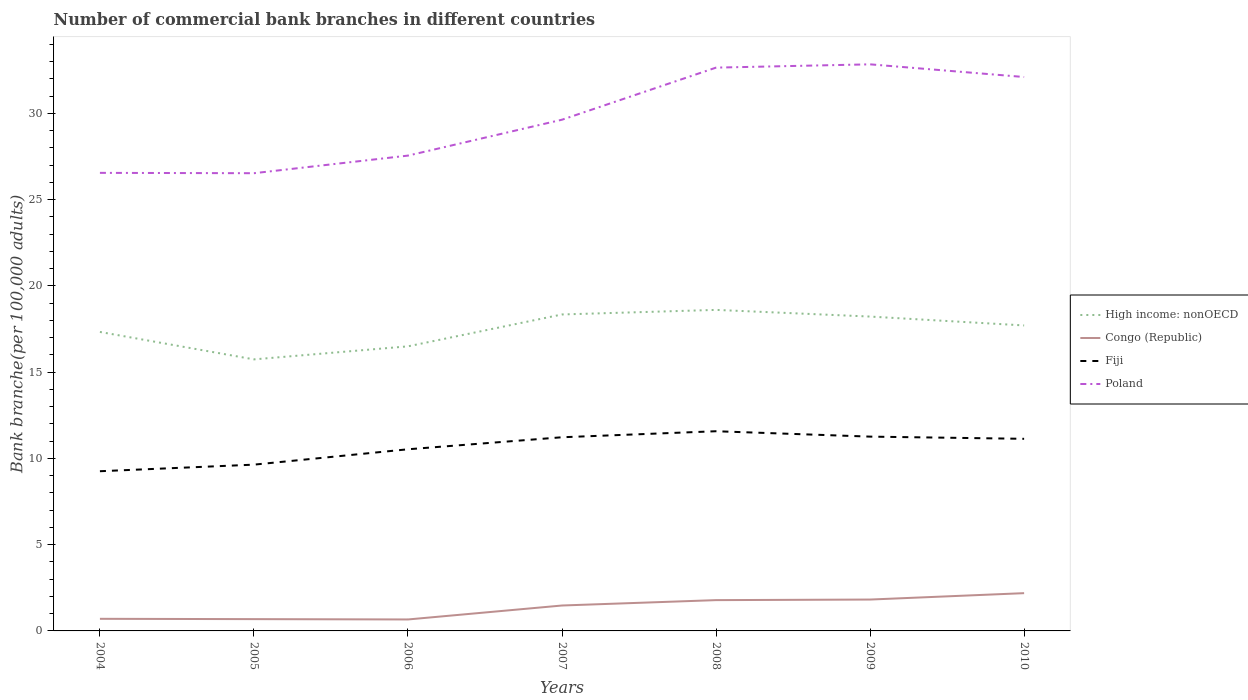Is the number of lines equal to the number of legend labels?
Ensure brevity in your answer.  Yes. Across all years, what is the maximum number of commercial bank branches in Congo (Republic)?
Offer a terse response. 0.66. What is the total number of commercial bank branches in Congo (Republic) in the graph?
Provide a short and direct response. -0.77. What is the difference between the highest and the second highest number of commercial bank branches in Congo (Republic)?
Offer a very short reply. 1.52. What is the difference between the highest and the lowest number of commercial bank branches in Fiji?
Make the answer very short. 4. Is the number of commercial bank branches in Fiji strictly greater than the number of commercial bank branches in High income: nonOECD over the years?
Your response must be concise. Yes. How many lines are there?
Provide a succinct answer. 4. How many years are there in the graph?
Make the answer very short. 7. What is the difference between two consecutive major ticks on the Y-axis?
Your answer should be compact. 5. Are the values on the major ticks of Y-axis written in scientific E-notation?
Provide a succinct answer. No. How many legend labels are there?
Provide a short and direct response. 4. How are the legend labels stacked?
Ensure brevity in your answer.  Vertical. What is the title of the graph?
Ensure brevity in your answer.  Number of commercial bank branches in different countries. Does "Nepal" appear as one of the legend labels in the graph?
Provide a succinct answer. No. What is the label or title of the X-axis?
Your response must be concise. Years. What is the label or title of the Y-axis?
Your response must be concise. Bank branche(per 100,0 adults). What is the Bank branche(per 100,000 adults) in High income: nonOECD in 2004?
Ensure brevity in your answer.  17.33. What is the Bank branche(per 100,000 adults) in Congo (Republic) in 2004?
Provide a succinct answer. 0.7. What is the Bank branche(per 100,000 adults) in Fiji in 2004?
Make the answer very short. 9.26. What is the Bank branche(per 100,000 adults) in Poland in 2004?
Give a very brief answer. 26.55. What is the Bank branche(per 100,000 adults) of High income: nonOECD in 2005?
Make the answer very short. 15.74. What is the Bank branche(per 100,000 adults) of Congo (Republic) in 2005?
Your response must be concise. 0.68. What is the Bank branche(per 100,000 adults) in Fiji in 2005?
Provide a succinct answer. 9.64. What is the Bank branche(per 100,000 adults) of Poland in 2005?
Ensure brevity in your answer.  26.53. What is the Bank branche(per 100,000 adults) of High income: nonOECD in 2006?
Keep it short and to the point. 16.5. What is the Bank branche(per 100,000 adults) in Congo (Republic) in 2006?
Offer a very short reply. 0.66. What is the Bank branche(per 100,000 adults) of Fiji in 2006?
Offer a very short reply. 10.53. What is the Bank branche(per 100,000 adults) in Poland in 2006?
Make the answer very short. 27.55. What is the Bank branche(per 100,000 adults) of High income: nonOECD in 2007?
Offer a very short reply. 18.34. What is the Bank branche(per 100,000 adults) of Congo (Republic) in 2007?
Provide a succinct answer. 1.47. What is the Bank branche(per 100,000 adults) in Fiji in 2007?
Offer a very short reply. 11.23. What is the Bank branche(per 100,000 adults) of Poland in 2007?
Make the answer very short. 29.63. What is the Bank branche(per 100,000 adults) of High income: nonOECD in 2008?
Provide a succinct answer. 18.61. What is the Bank branche(per 100,000 adults) in Congo (Republic) in 2008?
Make the answer very short. 1.79. What is the Bank branche(per 100,000 adults) of Fiji in 2008?
Provide a succinct answer. 11.57. What is the Bank branche(per 100,000 adults) of Poland in 2008?
Provide a succinct answer. 32.65. What is the Bank branche(per 100,000 adults) in High income: nonOECD in 2009?
Your answer should be compact. 18.22. What is the Bank branche(per 100,000 adults) of Congo (Republic) in 2009?
Make the answer very short. 1.82. What is the Bank branche(per 100,000 adults) in Fiji in 2009?
Your answer should be very brief. 11.26. What is the Bank branche(per 100,000 adults) of Poland in 2009?
Make the answer very short. 32.84. What is the Bank branche(per 100,000 adults) in High income: nonOECD in 2010?
Provide a succinct answer. 17.71. What is the Bank branche(per 100,000 adults) in Congo (Republic) in 2010?
Your answer should be compact. 2.19. What is the Bank branche(per 100,000 adults) in Fiji in 2010?
Your answer should be very brief. 11.14. What is the Bank branche(per 100,000 adults) in Poland in 2010?
Offer a very short reply. 32.11. Across all years, what is the maximum Bank branche(per 100,000 adults) in High income: nonOECD?
Ensure brevity in your answer.  18.61. Across all years, what is the maximum Bank branche(per 100,000 adults) in Congo (Republic)?
Offer a very short reply. 2.19. Across all years, what is the maximum Bank branche(per 100,000 adults) in Fiji?
Keep it short and to the point. 11.57. Across all years, what is the maximum Bank branche(per 100,000 adults) of Poland?
Your answer should be compact. 32.84. Across all years, what is the minimum Bank branche(per 100,000 adults) in High income: nonOECD?
Offer a terse response. 15.74. Across all years, what is the minimum Bank branche(per 100,000 adults) of Congo (Republic)?
Your answer should be very brief. 0.66. Across all years, what is the minimum Bank branche(per 100,000 adults) in Fiji?
Make the answer very short. 9.26. Across all years, what is the minimum Bank branche(per 100,000 adults) in Poland?
Give a very brief answer. 26.53. What is the total Bank branche(per 100,000 adults) of High income: nonOECD in the graph?
Provide a short and direct response. 122.44. What is the total Bank branche(per 100,000 adults) in Congo (Republic) in the graph?
Your answer should be compact. 9.32. What is the total Bank branche(per 100,000 adults) in Fiji in the graph?
Offer a very short reply. 74.62. What is the total Bank branche(per 100,000 adults) of Poland in the graph?
Keep it short and to the point. 207.87. What is the difference between the Bank branche(per 100,000 adults) of High income: nonOECD in 2004 and that in 2005?
Ensure brevity in your answer.  1.59. What is the difference between the Bank branche(per 100,000 adults) in Congo (Republic) in 2004 and that in 2005?
Offer a terse response. 0.02. What is the difference between the Bank branche(per 100,000 adults) of Fiji in 2004 and that in 2005?
Keep it short and to the point. -0.38. What is the difference between the Bank branche(per 100,000 adults) of Poland in 2004 and that in 2005?
Provide a short and direct response. 0.02. What is the difference between the Bank branche(per 100,000 adults) of High income: nonOECD in 2004 and that in 2006?
Your answer should be compact. 0.83. What is the difference between the Bank branche(per 100,000 adults) of Congo (Republic) in 2004 and that in 2006?
Your response must be concise. 0.04. What is the difference between the Bank branche(per 100,000 adults) in Fiji in 2004 and that in 2006?
Your answer should be compact. -1.27. What is the difference between the Bank branche(per 100,000 adults) of Poland in 2004 and that in 2006?
Your response must be concise. -1. What is the difference between the Bank branche(per 100,000 adults) in High income: nonOECD in 2004 and that in 2007?
Your answer should be very brief. -1.01. What is the difference between the Bank branche(per 100,000 adults) of Congo (Republic) in 2004 and that in 2007?
Give a very brief answer. -0.77. What is the difference between the Bank branche(per 100,000 adults) in Fiji in 2004 and that in 2007?
Your answer should be very brief. -1.97. What is the difference between the Bank branche(per 100,000 adults) in Poland in 2004 and that in 2007?
Offer a terse response. -3.08. What is the difference between the Bank branche(per 100,000 adults) in High income: nonOECD in 2004 and that in 2008?
Your response must be concise. -1.28. What is the difference between the Bank branche(per 100,000 adults) in Congo (Republic) in 2004 and that in 2008?
Your answer should be very brief. -1.08. What is the difference between the Bank branche(per 100,000 adults) of Fiji in 2004 and that in 2008?
Keep it short and to the point. -2.32. What is the difference between the Bank branche(per 100,000 adults) in Poland in 2004 and that in 2008?
Give a very brief answer. -6.1. What is the difference between the Bank branche(per 100,000 adults) in High income: nonOECD in 2004 and that in 2009?
Offer a very short reply. -0.89. What is the difference between the Bank branche(per 100,000 adults) of Congo (Republic) in 2004 and that in 2009?
Offer a very short reply. -1.12. What is the difference between the Bank branche(per 100,000 adults) of Fiji in 2004 and that in 2009?
Keep it short and to the point. -2.01. What is the difference between the Bank branche(per 100,000 adults) of Poland in 2004 and that in 2009?
Give a very brief answer. -6.29. What is the difference between the Bank branche(per 100,000 adults) of High income: nonOECD in 2004 and that in 2010?
Make the answer very short. -0.38. What is the difference between the Bank branche(per 100,000 adults) of Congo (Republic) in 2004 and that in 2010?
Offer a very short reply. -1.49. What is the difference between the Bank branche(per 100,000 adults) in Fiji in 2004 and that in 2010?
Keep it short and to the point. -1.88. What is the difference between the Bank branche(per 100,000 adults) of Poland in 2004 and that in 2010?
Provide a succinct answer. -5.56. What is the difference between the Bank branche(per 100,000 adults) of High income: nonOECD in 2005 and that in 2006?
Provide a short and direct response. -0.76. What is the difference between the Bank branche(per 100,000 adults) in Congo (Republic) in 2005 and that in 2006?
Your response must be concise. 0.02. What is the difference between the Bank branche(per 100,000 adults) in Fiji in 2005 and that in 2006?
Your answer should be compact. -0.89. What is the difference between the Bank branche(per 100,000 adults) of Poland in 2005 and that in 2006?
Your answer should be very brief. -1.02. What is the difference between the Bank branche(per 100,000 adults) of High income: nonOECD in 2005 and that in 2007?
Your answer should be compact. -2.6. What is the difference between the Bank branche(per 100,000 adults) in Congo (Republic) in 2005 and that in 2007?
Keep it short and to the point. -0.79. What is the difference between the Bank branche(per 100,000 adults) in Fiji in 2005 and that in 2007?
Offer a terse response. -1.59. What is the difference between the Bank branche(per 100,000 adults) in Poland in 2005 and that in 2007?
Give a very brief answer. -3.1. What is the difference between the Bank branche(per 100,000 adults) in High income: nonOECD in 2005 and that in 2008?
Your answer should be compact. -2.87. What is the difference between the Bank branche(per 100,000 adults) of Congo (Republic) in 2005 and that in 2008?
Provide a succinct answer. -1.1. What is the difference between the Bank branche(per 100,000 adults) in Fiji in 2005 and that in 2008?
Provide a succinct answer. -1.94. What is the difference between the Bank branche(per 100,000 adults) in Poland in 2005 and that in 2008?
Give a very brief answer. -6.12. What is the difference between the Bank branche(per 100,000 adults) of High income: nonOECD in 2005 and that in 2009?
Provide a succinct answer. -2.48. What is the difference between the Bank branche(per 100,000 adults) of Congo (Republic) in 2005 and that in 2009?
Keep it short and to the point. -1.13. What is the difference between the Bank branche(per 100,000 adults) in Fiji in 2005 and that in 2009?
Offer a very short reply. -1.62. What is the difference between the Bank branche(per 100,000 adults) of Poland in 2005 and that in 2009?
Ensure brevity in your answer.  -6.31. What is the difference between the Bank branche(per 100,000 adults) in High income: nonOECD in 2005 and that in 2010?
Your response must be concise. -1.97. What is the difference between the Bank branche(per 100,000 adults) in Congo (Republic) in 2005 and that in 2010?
Your answer should be very brief. -1.51. What is the difference between the Bank branche(per 100,000 adults) of Fiji in 2005 and that in 2010?
Provide a succinct answer. -1.5. What is the difference between the Bank branche(per 100,000 adults) in Poland in 2005 and that in 2010?
Ensure brevity in your answer.  -5.58. What is the difference between the Bank branche(per 100,000 adults) of High income: nonOECD in 2006 and that in 2007?
Provide a short and direct response. -1.85. What is the difference between the Bank branche(per 100,000 adults) of Congo (Republic) in 2006 and that in 2007?
Offer a very short reply. -0.81. What is the difference between the Bank branche(per 100,000 adults) of Fiji in 2006 and that in 2007?
Your answer should be very brief. -0.7. What is the difference between the Bank branche(per 100,000 adults) in Poland in 2006 and that in 2007?
Ensure brevity in your answer.  -2.08. What is the difference between the Bank branche(per 100,000 adults) of High income: nonOECD in 2006 and that in 2008?
Offer a terse response. -2.11. What is the difference between the Bank branche(per 100,000 adults) of Congo (Republic) in 2006 and that in 2008?
Offer a very short reply. -1.12. What is the difference between the Bank branche(per 100,000 adults) in Fiji in 2006 and that in 2008?
Give a very brief answer. -1.05. What is the difference between the Bank branche(per 100,000 adults) of Poland in 2006 and that in 2008?
Your response must be concise. -5.1. What is the difference between the Bank branche(per 100,000 adults) of High income: nonOECD in 2006 and that in 2009?
Give a very brief answer. -1.73. What is the difference between the Bank branche(per 100,000 adults) in Congo (Republic) in 2006 and that in 2009?
Make the answer very short. -1.15. What is the difference between the Bank branche(per 100,000 adults) of Fiji in 2006 and that in 2009?
Offer a very short reply. -0.73. What is the difference between the Bank branche(per 100,000 adults) of Poland in 2006 and that in 2009?
Ensure brevity in your answer.  -5.29. What is the difference between the Bank branche(per 100,000 adults) in High income: nonOECD in 2006 and that in 2010?
Give a very brief answer. -1.21. What is the difference between the Bank branche(per 100,000 adults) of Congo (Republic) in 2006 and that in 2010?
Your answer should be compact. -1.52. What is the difference between the Bank branche(per 100,000 adults) of Fiji in 2006 and that in 2010?
Your answer should be compact. -0.61. What is the difference between the Bank branche(per 100,000 adults) in Poland in 2006 and that in 2010?
Your answer should be compact. -4.56. What is the difference between the Bank branche(per 100,000 adults) of High income: nonOECD in 2007 and that in 2008?
Your answer should be very brief. -0.26. What is the difference between the Bank branche(per 100,000 adults) of Congo (Republic) in 2007 and that in 2008?
Keep it short and to the point. -0.31. What is the difference between the Bank branche(per 100,000 adults) in Fiji in 2007 and that in 2008?
Ensure brevity in your answer.  -0.35. What is the difference between the Bank branche(per 100,000 adults) of Poland in 2007 and that in 2008?
Your answer should be very brief. -3.02. What is the difference between the Bank branche(per 100,000 adults) of High income: nonOECD in 2007 and that in 2009?
Keep it short and to the point. 0.12. What is the difference between the Bank branche(per 100,000 adults) of Congo (Republic) in 2007 and that in 2009?
Keep it short and to the point. -0.35. What is the difference between the Bank branche(per 100,000 adults) of Fiji in 2007 and that in 2009?
Give a very brief answer. -0.04. What is the difference between the Bank branche(per 100,000 adults) in Poland in 2007 and that in 2009?
Provide a short and direct response. -3.21. What is the difference between the Bank branche(per 100,000 adults) of High income: nonOECD in 2007 and that in 2010?
Provide a short and direct response. 0.64. What is the difference between the Bank branche(per 100,000 adults) of Congo (Republic) in 2007 and that in 2010?
Offer a terse response. -0.72. What is the difference between the Bank branche(per 100,000 adults) of Fiji in 2007 and that in 2010?
Ensure brevity in your answer.  0.09. What is the difference between the Bank branche(per 100,000 adults) of Poland in 2007 and that in 2010?
Give a very brief answer. -2.47. What is the difference between the Bank branche(per 100,000 adults) in High income: nonOECD in 2008 and that in 2009?
Offer a terse response. 0.39. What is the difference between the Bank branche(per 100,000 adults) of Congo (Republic) in 2008 and that in 2009?
Keep it short and to the point. -0.03. What is the difference between the Bank branche(per 100,000 adults) in Fiji in 2008 and that in 2009?
Your response must be concise. 0.31. What is the difference between the Bank branche(per 100,000 adults) of Poland in 2008 and that in 2009?
Your response must be concise. -0.19. What is the difference between the Bank branche(per 100,000 adults) in High income: nonOECD in 2008 and that in 2010?
Provide a short and direct response. 0.9. What is the difference between the Bank branche(per 100,000 adults) of Congo (Republic) in 2008 and that in 2010?
Keep it short and to the point. -0.4. What is the difference between the Bank branche(per 100,000 adults) of Fiji in 2008 and that in 2010?
Make the answer very short. 0.44. What is the difference between the Bank branche(per 100,000 adults) in Poland in 2008 and that in 2010?
Provide a succinct answer. 0.54. What is the difference between the Bank branche(per 100,000 adults) of High income: nonOECD in 2009 and that in 2010?
Provide a short and direct response. 0.51. What is the difference between the Bank branche(per 100,000 adults) of Congo (Republic) in 2009 and that in 2010?
Give a very brief answer. -0.37. What is the difference between the Bank branche(per 100,000 adults) of Fiji in 2009 and that in 2010?
Make the answer very short. 0.13. What is the difference between the Bank branche(per 100,000 adults) of Poland in 2009 and that in 2010?
Offer a very short reply. 0.74. What is the difference between the Bank branche(per 100,000 adults) in High income: nonOECD in 2004 and the Bank branche(per 100,000 adults) in Congo (Republic) in 2005?
Offer a very short reply. 16.65. What is the difference between the Bank branche(per 100,000 adults) in High income: nonOECD in 2004 and the Bank branche(per 100,000 adults) in Fiji in 2005?
Keep it short and to the point. 7.69. What is the difference between the Bank branche(per 100,000 adults) of High income: nonOECD in 2004 and the Bank branche(per 100,000 adults) of Poland in 2005?
Offer a terse response. -9.2. What is the difference between the Bank branche(per 100,000 adults) of Congo (Republic) in 2004 and the Bank branche(per 100,000 adults) of Fiji in 2005?
Make the answer very short. -8.94. What is the difference between the Bank branche(per 100,000 adults) of Congo (Republic) in 2004 and the Bank branche(per 100,000 adults) of Poland in 2005?
Your answer should be very brief. -25.83. What is the difference between the Bank branche(per 100,000 adults) in Fiji in 2004 and the Bank branche(per 100,000 adults) in Poland in 2005?
Offer a terse response. -17.27. What is the difference between the Bank branche(per 100,000 adults) in High income: nonOECD in 2004 and the Bank branche(per 100,000 adults) in Congo (Republic) in 2006?
Provide a short and direct response. 16.67. What is the difference between the Bank branche(per 100,000 adults) of High income: nonOECD in 2004 and the Bank branche(per 100,000 adults) of Fiji in 2006?
Provide a short and direct response. 6.8. What is the difference between the Bank branche(per 100,000 adults) in High income: nonOECD in 2004 and the Bank branche(per 100,000 adults) in Poland in 2006?
Offer a very short reply. -10.22. What is the difference between the Bank branche(per 100,000 adults) of Congo (Republic) in 2004 and the Bank branche(per 100,000 adults) of Fiji in 2006?
Ensure brevity in your answer.  -9.83. What is the difference between the Bank branche(per 100,000 adults) of Congo (Republic) in 2004 and the Bank branche(per 100,000 adults) of Poland in 2006?
Ensure brevity in your answer.  -26.85. What is the difference between the Bank branche(per 100,000 adults) of Fiji in 2004 and the Bank branche(per 100,000 adults) of Poland in 2006?
Keep it short and to the point. -18.3. What is the difference between the Bank branche(per 100,000 adults) of High income: nonOECD in 2004 and the Bank branche(per 100,000 adults) of Congo (Republic) in 2007?
Your answer should be compact. 15.86. What is the difference between the Bank branche(per 100,000 adults) in High income: nonOECD in 2004 and the Bank branche(per 100,000 adults) in Fiji in 2007?
Your answer should be very brief. 6.1. What is the difference between the Bank branche(per 100,000 adults) of High income: nonOECD in 2004 and the Bank branche(per 100,000 adults) of Poland in 2007?
Give a very brief answer. -12.3. What is the difference between the Bank branche(per 100,000 adults) in Congo (Republic) in 2004 and the Bank branche(per 100,000 adults) in Fiji in 2007?
Keep it short and to the point. -10.52. What is the difference between the Bank branche(per 100,000 adults) of Congo (Republic) in 2004 and the Bank branche(per 100,000 adults) of Poland in 2007?
Your answer should be very brief. -28.93. What is the difference between the Bank branche(per 100,000 adults) of Fiji in 2004 and the Bank branche(per 100,000 adults) of Poland in 2007?
Your response must be concise. -20.38. What is the difference between the Bank branche(per 100,000 adults) of High income: nonOECD in 2004 and the Bank branche(per 100,000 adults) of Congo (Republic) in 2008?
Keep it short and to the point. 15.54. What is the difference between the Bank branche(per 100,000 adults) in High income: nonOECD in 2004 and the Bank branche(per 100,000 adults) in Fiji in 2008?
Keep it short and to the point. 5.76. What is the difference between the Bank branche(per 100,000 adults) in High income: nonOECD in 2004 and the Bank branche(per 100,000 adults) in Poland in 2008?
Your answer should be compact. -15.32. What is the difference between the Bank branche(per 100,000 adults) of Congo (Republic) in 2004 and the Bank branche(per 100,000 adults) of Fiji in 2008?
Keep it short and to the point. -10.87. What is the difference between the Bank branche(per 100,000 adults) in Congo (Republic) in 2004 and the Bank branche(per 100,000 adults) in Poland in 2008?
Make the answer very short. -31.95. What is the difference between the Bank branche(per 100,000 adults) in Fiji in 2004 and the Bank branche(per 100,000 adults) in Poland in 2008?
Offer a very short reply. -23.39. What is the difference between the Bank branche(per 100,000 adults) of High income: nonOECD in 2004 and the Bank branche(per 100,000 adults) of Congo (Republic) in 2009?
Your response must be concise. 15.51. What is the difference between the Bank branche(per 100,000 adults) of High income: nonOECD in 2004 and the Bank branche(per 100,000 adults) of Fiji in 2009?
Provide a short and direct response. 6.07. What is the difference between the Bank branche(per 100,000 adults) in High income: nonOECD in 2004 and the Bank branche(per 100,000 adults) in Poland in 2009?
Make the answer very short. -15.51. What is the difference between the Bank branche(per 100,000 adults) in Congo (Republic) in 2004 and the Bank branche(per 100,000 adults) in Fiji in 2009?
Give a very brief answer. -10.56. What is the difference between the Bank branche(per 100,000 adults) in Congo (Republic) in 2004 and the Bank branche(per 100,000 adults) in Poland in 2009?
Keep it short and to the point. -32.14. What is the difference between the Bank branche(per 100,000 adults) of Fiji in 2004 and the Bank branche(per 100,000 adults) of Poland in 2009?
Offer a terse response. -23.59. What is the difference between the Bank branche(per 100,000 adults) in High income: nonOECD in 2004 and the Bank branche(per 100,000 adults) in Congo (Republic) in 2010?
Keep it short and to the point. 15.14. What is the difference between the Bank branche(per 100,000 adults) in High income: nonOECD in 2004 and the Bank branche(per 100,000 adults) in Fiji in 2010?
Provide a succinct answer. 6.19. What is the difference between the Bank branche(per 100,000 adults) of High income: nonOECD in 2004 and the Bank branche(per 100,000 adults) of Poland in 2010?
Provide a short and direct response. -14.78. What is the difference between the Bank branche(per 100,000 adults) in Congo (Republic) in 2004 and the Bank branche(per 100,000 adults) in Fiji in 2010?
Provide a short and direct response. -10.43. What is the difference between the Bank branche(per 100,000 adults) in Congo (Republic) in 2004 and the Bank branche(per 100,000 adults) in Poland in 2010?
Make the answer very short. -31.4. What is the difference between the Bank branche(per 100,000 adults) in Fiji in 2004 and the Bank branche(per 100,000 adults) in Poland in 2010?
Provide a short and direct response. -22.85. What is the difference between the Bank branche(per 100,000 adults) in High income: nonOECD in 2005 and the Bank branche(per 100,000 adults) in Congo (Republic) in 2006?
Ensure brevity in your answer.  15.08. What is the difference between the Bank branche(per 100,000 adults) in High income: nonOECD in 2005 and the Bank branche(per 100,000 adults) in Fiji in 2006?
Ensure brevity in your answer.  5.21. What is the difference between the Bank branche(per 100,000 adults) of High income: nonOECD in 2005 and the Bank branche(per 100,000 adults) of Poland in 2006?
Ensure brevity in your answer.  -11.81. What is the difference between the Bank branche(per 100,000 adults) in Congo (Republic) in 2005 and the Bank branche(per 100,000 adults) in Fiji in 2006?
Provide a short and direct response. -9.85. What is the difference between the Bank branche(per 100,000 adults) of Congo (Republic) in 2005 and the Bank branche(per 100,000 adults) of Poland in 2006?
Ensure brevity in your answer.  -26.87. What is the difference between the Bank branche(per 100,000 adults) of Fiji in 2005 and the Bank branche(per 100,000 adults) of Poland in 2006?
Your answer should be very brief. -17.91. What is the difference between the Bank branche(per 100,000 adults) of High income: nonOECD in 2005 and the Bank branche(per 100,000 adults) of Congo (Republic) in 2007?
Offer a very short reply. 14.27. What is the difference between the Bank branche(per 100,000 adults) in High income: nonOECD in 2005 and the Bank branche(per 100,000 adults) in Fiji in 2007?
Ensure brevity in your answer.  4.51. What is the difference between the Bank branche(per 100,000 adults) of High income: nonOECD in 2005 and the Bank branche(per 100,000 adults) of Poland in 2007?
Provide a succinct answer. -13.89. What is the difference between the Bank branche(per 100,000 adults) in Congo (Republic) in 2005 and the Bank branche(per 100,000 adults) in Fiji in 2007?
Give a very brief answer. -10.54. What is the difference between the Bank branche(per 100,000 adults) in Congo (Republic) in 2005 and the Bank branche(per 100,000 adults) in Poland in 2007?
Offer a terse response. -28.95. What is the difference between the Bank branche(per 100,000 adults) in Fiji in 2005 and the Bank branche(per 100,000 adults) in Poland in 2007?
Your response must be concise. -19.99. What is the difference between the Bank branche(per 100,000 adults) in High income: nonOECD in 2005 and the Bank branche(per 100,000 adults) in Congo (Republic) in 2008?
Offer a terse response. 13.95. What is the difference between the Bank branche(per 100,000 adults) of High income: nonOECD in 2005 and the Bank branche(per 100,000 adults) of Fiji in 2008?
Give a very brief answer. 4.17. What is the difference between the Bank branche(per 100,000 adults) of High income: nonOECD in 2005 and the Bank branche(per 100,000 adults) of Poland in 2008?
Offer a terse response. -16.91. What is the difference between the Bank branche(per 100,000 adults) in Congo (Republic) in 2005 and the Bank branche(per 100,000 adults) in Fiji in 2008?
Make the answer very short. -10.89. What is the difference between the Bank branche(per 100,000 adults) in Congo (Republic) in 2005 and the Bank branche(per 100,000 adults) in Poland in 2008?
Make the answer very short. -31.97. What is the difference between the Bank branche(per 100,000 adults) in Fiji in 2005 and the Bank branche(per 100,000 adults) in Poland in 2008?
Provide a short and direct response. -23.01. What is the difference between the Bank branche(per 100,000 adults) in High income: nonOECD in 2005 and the Bank branche(per 100,000 adults) in Congo (Republic) in 2009?
Make the answer very short. 13.92. What is the difference between the Bank branche(per 100,000 adults) of High income: nonOECD in 2005 and the Bank branche(per 100,000 adults) of Fiji in 2009?
Provide a short and direct response. 4.48. What is the difference between the Bank branche(per 100,000 adults) of High income: nonOECD in 2005 and the Bank branche(per 100,000 adults) of Poland in 2009?
Offer a terse response. -17.1. What is the difference between the Bank branche(per 100,000 adults) of Congo (Republic) in 2005 and the Bank branche(per 100,000 adults) of Fiji in 2009?
Provide a short and direct response. -10.58. What is the difference between the Bank branche(per 100,000 adults) of Congo (Republic) in 2005 and the Bank branche(per 100,000 adults) of Poland in 2009?
Your answer should be compact. -32.16. What is the difference between the Bank branche(per 100,000 adults) of Fiji in 2005 and the Bank branche(per 100,000 adults) of Poland in 2009?
Give a very brief answer. -23.2. What is the difference between the Bank branche(per 100,000 adults) in High income: nonOECD in 2005 and the Bank branche(per 100,000 adults) in Congo (Republic) in 2010?
Your answer should be very brief. 13.55. What is the difference between the Bank branche(per 100,000 adults) of High income: nonOECD in 2005 and the Bank branche(per 100,000 adults) of Fiji in 2010?
Your response must be concise. 4.6. What is the difference between the Bank branche(per 100,000 adults) of High income: nonOECD in 2005 and the Bank branche(per 100,000 adults) of Poland in 2010?
Offer a terse response. -16.37. What is the difference between the Bank branche(per 100,000 adults) in Congo (Republic) in 2005 and the Bank branche(per 100,000 adults) in Fiji in 2010?
Your answer should be compact. -10.45. What is the difference between the Bank branche(per 100,000 adults) in Congo (Republic) in 2005 and the Bank branche(per 100,000 adults) in Poland in 2010?
Keep it short and to the point. -31.42. What is the difference between the Bank branche(per 100,000 adults) in Fiji in 2005 and the Bank branche(per 100,000 adults) in Poland in 2010?
Your answer should be compact. -22.47. What is the difference between the Bank branche(per 100,000 adults) in High income: nonOECD in 2006 and the Bank branche(per 100,000 adults) in Congo (Republic) in 2007?
Your answer should be very brief. 15.02. What is the difference between the Bank branche(per 100,000 adults) in High income: nonOECD in 2006 and the Bank branche(per 100,000 adults) in Fiji in 2007?
Make the answer very short. 5.27. What is the difference between the Bank branche(per 100,000 adults) of High income: nonOECD in 2006 and the Bank branche(per 100,000 adults) of Poland in 2007?
Offer a terse response. -13.14. What is the difference between the Bank branche(per 100,000 adults) in Congo (Republic) in 2006 and the Bank branche(per 100,000 adults) in Fiji in 2007?
Ensure brevity in your answer.  -10.56. What is the difference between the Bank branche(per 100,000 adults) in Congo (Republic) in 2006 and the Bank branche(per 100,000 adults) in Poland in 2007?
Your response must be concise. -28.97. What is the difference between the Bank branche(per 100,000 adults) in Fiji in 2006 and the Bank branche(per 100,000 adults) in Poland in 2007?
Make the answer very short. -19.1. What is the difference between the Bank branche(per 100,000 adults) in High income: nonOECD in 2006 and the Bank branche(per 100,000 adults) in Congo (Republic) in 2008?
Make the answer very short. 14.71. What is the difference between the Bank branche(per 100,000 adults) of High income: nonOECD in 2006 and the Bank branche(per 100,000 adults) of Fiji in 2008?
Offer a terse response. 4.92. What is the difference between the Bank branche(per 100,000 adults) of High income: nonOECD in 2006 and the Bank branche(per 100,000 adults) of Poland in 2008?
Make the answer very short. -16.16. What is the difference between the Bank branche(per 100,000 adults) in Congo (Republic) in 2006 and the Bank branche(per 100,000 adults) in Fiji in 2008?
Your answer should be compact. -10.91. What is the difference between the Bank branche(per 100,000 adults) of Congo (Republic) in 2006 and the Bank branche(per 100,000 adults) of Poland in 2008?
Your answer should be very brief. -31.99. What is the difference between the Bank branche(per 100,000 adults) of Fiji in 2006 and the Bank branche(per 100,000 adults) of Poland in 2008?
Your answer should be very brief. -22.12. What is the difference between the Bank branche(per 100,000 adults) in High income: nonOECD in 2006 and the Bank branche(per 100,000 adults) in Congo (Republic) in 2009?
Your answer should be very brief. 14.68. What is the difference between the Bank branche(per 100,000 adults) in High income: nonOECD in 2006 and the Bank branche(per 100,000 adults) in Fiji in 2009?
Your answer should be very brief. 5.23. What is the difference between the Bank branche(per 100,000 adults) of High income: nonOECD in 2006 and the Bank branche(per 100,000 adults) of Poland in 2009?
Make the answer very short. -16.35. What is the difference between the Bank branche(per 100,000 adults) in Congo (Republic) in 2006 and the Bank branche(per 100,000 adults) in Fiji in 2009?
Ensure brevity in your answer.  -10.6. What is the difference between the Bank branche(per 100,000 adults) in Congo (Republic) in 2006 and the Bank branche(per 100,000 adults) in Poland in 2009?
Make the answer very short. -32.18. What is the difference between the Bank branche(per 100,000 adults) of Fiji in 2006 and the Bank branche(per 100,000 adults) of Poland in 2009?
Provide a short and direct response. -22.31. What is the difference between the Bank branche(per 100,000 adults) in High income: nonOECD in 2006 and the Bank branche(per 100,000 adults) in Congo (Republic) in 2010?
Your response must be concise. 14.31. What is the difference between the Bank branche(per 100,000 adults) of High income: nonOECD in 2006 and the Bank branche(per 100,000 adults) of Fiji in 2010?
Provide a short and direct response. 5.36. What is the difference between the Bank branche(per 100,000 adults) of High income: nonOECD in 2006 and the Bank branche(per 100,000 adults) of Poland in 2010?
Offer a very short reply. -15.61. What is the difference between the Bank branche(per 100,000 adults) in Congo (Republic) in 2006 and the Bank branche(per 100,000 adults) in Fiji in 2010?
Make the answer very short. -10.47. What is the difference between the Bank branche(per 100,000 adults) in Congo (Republic) in 2006 and the Bank branche(per 100,000 adults) in Poland in 2010?
Make the answer very short. -31.44. What is the difference between the Bank branche(per 100,000 adults) of Fiji in 2006 and the Bank branche(per 100,000 adults) of Poland in 2010?
Make the answer very short. -21.58. What is the difference between the Bank branche(per 100,000 adults) in High income: nonOECD in 2007 and the Bank branche(per 100,000 adults) in Congo (Republic) in 2008?
Your answer should be very brief. 16.56. What is the difference between the Bank branche(per 100,000 adults) in High income: nonOECD in 2007 and the Bank branche(per 100,000 adults) in Fiji in 2008?
Your answer should be compact. 6.77. What is the difference between the Bank branche(per 100,000 adults) of High income: nonOECD in 2007 and the Bank branche(per 100,000 adults) of Poland in 2008?
Your answer should be compact. -14.31. What is the difference between the Bank branche(per 100,000 adults) in Congo (Republic) in 2007 and the Bank branche(per 100,000 adults) in Fiji in 2008?
Offer a terse response. -10.1. What is the difference between the Bank branche(per 100,000 adults) of Congo (Republic) in 2007 and the Bank branche(per 100,000 adults) of Poland in 2008?
Make the answer very short. -31.18. What is the difference between the Bank branche(per 100,000 adults) in Fiji in 2007 and the Bank branche(per 100,000 adults) in Poland in 2008?
Your response must be concise. -21.43. What is the difference between the Bank branche(per 100,000 adults) in High income: nonOECD in 2007 and the Bank branche(per 100,000 adults) in Congo (Republic) in 2009?
Offer a very short reply. 16.52. What is the difference between the Bank branche(per 100,000 adults) in High income: nonOECD in 2007 and the Bank branche(per 100,000 adults) in Fiji in 2009?
Your response must be concise. 7.08. What is the difference between the Bank branche(per 100,000 adults) of High income: nonOECD in 2007 and the Bank branche(per 100,000 adults) of Poland in 2009?
Offer a terse response. -14.5. What is the difference between the Bank branche(per 100,000 adults) in Congo (Republic) in 2007 and the Bank branche(per 100,000 adults) in Fiji in 2009?
Provide a succinct answer. -9.79. What is the difference between the Bank branche(per 100,000 adults) in Congo (Republic) in 2007 and the Bank branche(per 100,000 adults) in Poland in 2009?
Your response must be concise. -31.37. What is the difference between the Bank branche(per 100,000 adults) in Fiji in 2007 and the Bank branche(per 100,000 adults) in Poland in 2009?
Provide a succinct answer. -21.62. What is the difference between the Bank branche(per 100,000 adults) of High income: nonOECD in 2007 and the Bank branche(per 100,000 adults) of Congo (Republic) in 2010?
Your answer should be compact. 16.15. What is the difference between the Bank branche(per 100,000 adults) of High income: nonOECD in 2007 and the Bank branche(per 100,000 adults) of Fiji in 2010?
Offer a very short reply. 7.21. What is the difference between the Bank branche(per 100,000 adults) of High income: nonOECD in 2007 and the Bank branche(per 100,000 adults) of Poland in 2010?
Offer a terse response. -13.76. What is the difference between the Bank branche(per 100,000 adults) of Congo (Republic) in 2007 and the Bank branche(per 100,000 adults) of Fiji in 2010?
Your response must be concise. -9.66. What is the difference between the Bank branche(per 100,000 adults) of Congo (Republic) in 2007 and the Bank branche(per 100,000 adults) of Poland in 2010?
Make the answer very short. -30.63. What is the difference between the Bank branche(per 100,000 adults) of Fiji in 2007 and the Bank branche(per 100,000 adults) of Poland in 2010?
Ensure brevity in your answer.  -20.88. What is the difference between the Bank branche(per 100,000 adults) in High income: nonOECD in 2008 and the Bank branche(per 100,000 adults) in Congo (Republic) in 2009?
Give a very brief answer. 16.79. What is the difference between the Bank branche(per 100,000 adults) in High income: nonOECD in 2008 and the Bank branche(per 100,000 adults) in Fiji in 2009?
Offer a terse response. 7.35. What is the difference between the Bank branche(per 100,000 adults) of High income: nonOECD in 2008 and the Bank branche(per 100,000 adults) of Poland in 2009?
Your answer should be very brief. -14.23. What is the difference between the Bank branche(per 100,000 adults) of Congo (Republic) in 2008 and the Bank branche(per 100,000 adults) of Fiji in 2009?
Provide a succinct answer. -9.48. What is the difference between the Bank branche(per 100,000 adults) of Congo (Republic) in 2008 and the Bank branche(per 100,000 adults) of Poland in 2009?
Your answer should be very brief. -31.06. What is the difference between the Bank branche(per 100,000 adults) in Fiji in 2008 and the Bank branche(per 100,000 adults) in Poland in 2009?
Provide a succinct answer. -21.27. What is the difference between the Bank branche(per 100,000 adults) in High income: nonOECD in 2008 and the Bank branche(per 100,000 adults) in Congo (Republic) in 2010?
Make the answer very short. 16.42. What is the difference between the Bank branche(per 100,000 adults) in High income: nonOECD in 2008 and the Bank branche(per 100,000 adults) in Fiji in 2010?
Offer a very short reply. 7.47. What is the difference between the Bank branche(per 100,000 adults) of High income: nonOECD in 2008 and the Bank branche(per 100,000 adults) of Poland in 2010?
Your answer should be compact. -13.5. What is the difference between the Bank branche(per 100,000 adults) of Congo (Republic) in 2008 and the Bank branche(per 100,000 adults) of Fiji in 2010?
Offer a very short reply. -9.35. What is the difference between the Bank branche(per 100,000 adults) in Congo (Republic) in 2008 and the Bank branche(per 100,000 adults) in Poland in 2010?
Your answer should be compact. -30.32. What is the difference between the Bank branche(per 100,000 adults) of Fiji in 2008 and the Bank branche(per 100,000 adults) of Poland in 2010?
Your response must be concise. -20.53. What is the difference between the Bank branche(per 100,000 adults) of High income: nonOECD in 2009 and the Bank branche(per 100,000 adults) of Congo (Republic) in 2010?
Give a very brief answer. 16.03. What is the difference between the Bank branche(per 100,000 adults) in High income: nonOECD in 2009 and the Bank branche(per 100,000 adults) in Fiji in 2010?
Make the answer very short. 7.09. What is the difference between the Bank branche(per 100,000 adults) of High income: nonOECD in 2009 and the Bank branche(per 100,000 adults) of Poland in 2010?
Offer a very short reply. -13.89. What is the difference between the Bank branche(per 100,000 adults) of Congo (Republic) in 2009 and the Bank branche(per 100,000 adults) of Fiji in 2010?
Give a very brief answer. -9.32. What is the difference between the Bank branche(per 100,000 adults) in Congo (Republic) in 2009 and the Bank branche(per 100,000 adults) in Poland in 2010?
Provide a succinct answer. -30.29. What is the difference between the Bank branche(per 100,000 adults) of Fiji in 2009 and the Bank branche(per 100,000 adults) of Poland in 2010?
Provide a succinct answer. -20.84. What is the average Bank branche(per 100,000 adults) in High income: nonOECD per year?
Your response must be concise. 17.49. What is the average Bank branche(per 100,000 adults) of Congo (Republic) per year?
Your answer should be very brief. 1.33. What is the average Bank branche(per 100,000 adults) of Fiji per year?
Provide a succinct answer. 10.66. What is the average Bank branche(per 100,000 adults) of Poland per year?
Provide a short and direct response. 29.7. In the year 2004, what is the difference between the Bank branche(per 100,000 adults) of High income: nonOECD and Bank branche(per 100,000 adults) of Congo (Republic)?
Offer a very short reply. 16.63. In the year 2004, what is the difference between the Bank branche(per 100,000 adults) of High income: nonOECD and Bank branche(per 100,000 adults) of Fiji?
Your answer should be very brief. 8.07. In the year 2004, what is the difference between the Bank branche(per 100,000 adults) of High income: nonOECD and Bank branche(per 100,000 adults) of Poland?
Give a very brief answer. -9.22. In the year 2004, what is the difference between the Bank branche(per 100,000 adults) in Congo (Republic) and Bank branche(per 100,000 adults) in Fiji?
Your answer should be compact. -8.55. In the year 2004, what is the difference between the Bank branche(per 100,000 adults) in Congo (Republic) and Bank branche(per 100,000 adults) in Poland?
Ensure brevity in your answer.  -25.85. In the year 2004, what is the difference between the Bank branche(per 100,000 adults) in Fiji and Bank branche(per 100,000 adults) in Poland?
Keep it short and to the point. -17.29. In the year 2005, what is the difference between the Bank branche(per 100,000 adults) in High income: nonOECD and Bank branche(per 100,000 adults) in Congo (Republic)?
Offer a terse response. 15.06. In the year 2005, what is the difference between the Bank branche(per 100,000 adults) of High income: nonOECD and Bank branche(per 100,000 adults) of Fiji?
Give a very brief answer. 6.1. In the year 2005, what is the difference between the Bank branche(per 100,000 adults) of High income: nonOECD and Bank branche(per 100,000 adults) of Poland?
Provide a succinct answer. -10.79. In the year 2005, what is the difference between the Bank branche(per 100,000 adults) of Congo (Republic) and Bank branche(per 100,000 adults) of Fiji?
Keep it short and to the point. -8.95. In the year 2005, what is the difference between the Bank branche(per 100,000 adults) in Congo (Republic) and Bank branche(per 100,000 adults) in Poland?
Provide a succinct answer. -25.85. In the year 2005, what is the difference between the Bank branche(per 100,000 adults) of Fiji and Bank branche(per 100,000 adults) of Poland?
Ensure brevity in your answer.  -16.89. In the year 2006, what is the difference between the Bank branche(per 100,000 adults) of High income: nonOECD and Bank branche(per 100,000 adults) of Congo (Republic)?
Give a very brief answer. 15.83. In the year 2006, what is the difference between the Bank branche(per 100,000 adults) of High income: nonOECD and Bank branche(per 100,000 adults) of Fiji?
Your answer should be very brief. 5.97. In the year 2006, what is the difference between the Bank branche(per 100,000 adults) in High income: nonOECD and Bank branche(per 100,000 adults) in Poland?
Your answer should be compact. -11.06. In the year 2006, what is the difference between the Bank branche(per 100,000 adults) in Congo (Republic) and Bank branche(per 100,000 adults) in Fiji?
Provide a short and direct response. -9.86. In the year 2006, what is the difference between the Bank branche(per 100,000 adults) in Congo (Republic) and Bank branche(per 100,000 adults) in Poland?
Provide a succinct answer. -26.89. In the year 2006, what is the difference between the Bank branche(per 100,000 adults) in Fiji and Bank branche(per 100,000 adults) in Poland?
Offer a terse response. -17.02. In the year 2007, what is the difference between the Bank branche(per 100,000 adults) in High income: nonOECD and Bank branche(per 100,000 adults) in Congo (Republic)?
Offer a terse response. 16.87. In the year 2007, what is the difference between the Bank branche(per 100,000 adults) of High income: nonOECD and Bank branche(per 100,000 adults) of Fiji?
Make the answer very short. 7.12. In the year 2007, what is the difference between the Bank branche(per 100,000 adults) in High income: nonOECD and Bank branche(per 100,000 adults) in Poland?
Provide a short and direct response. -11.29. In the year 2007, what is the difference between the Bank branche(per 100,000 adults) of Congo (Republic) and Bank branche(per 100,000 adults) of Fiji?
Your response must be concise. -9.75. In the year 2007, what is the difference between the Bank branche(per 100,000 adults) in Congo (Republic) and Bank branche(per 100,000 adults) in Poland?
Give a very brief answer. -28.16. In the year 2007, what is the difference between the Bank branche(per 100,000 adults) of Fiji and Bank branche(per 100,000 adults) of Poland?
Your response must be concise. -18.41. In the year 2008, what is the difference between the Bank branche(per 100,000 adults) in High income: nonOECD and Bank branche(per 100,000 adults) in Congo (Republic)?
Provide a succinct answer. 16.82. In the year 2008, what is the difference between the Bank branche(per 100,000 adults) of High income: nonOECD and Bank branche(per 100,000 adults) of Fiji?
Your response must be concise. 7.03. In the year 2008, what is the difference between the Bank branche(per 100,000 adults) in High income: nonOECD and Bank branche(per 100,000 adults) in Poland?
Keep it short and to the point. -14.04. In the year 2008, what is the difference between the Bank branche(per 100,000 adults) of Congo (Republic) and Bank branche(per 100,000 adults) of Fiji?
Ensure brevity in your answer.  -9.79. In the year 2008, what is the difference between the Bank branche(per 100,000 adults) in Congo (Republic) and Bank branche(per 100,000 adults) in Poland?
Your answer should be very brief. -30.87. In the year 2008, what is the difference between the Bank branche(per 100,000 adults) of Fiji and Bank branche(per 100,000 adults) of Poland?
Make the answer very short. -21.08. In the year 2009, what is the difference between the Bank branche(per 100,000 adults) in High income: nonOECD and Bank branche(per 100,000 adults) in Congo (Republic)?
Give a very brief answer. 16.4. In the year 2009, what is the difference between the Bank branche(per 100,000 adults) in High income: nonOECD and Bank branche(per 100,000 adults) in Fiji?
Give a very brief answer. 6.96. In the year 2009, what is the difference between the Bank branche(per 100,000 adults) in High income: nonOECD and Bank branche(per 100,000 adults) in Poland?
Your answer should be very brief. -14.62. In the year 2009, what is the difference between the Bank branche(per 100,000 adults) of Congo (Republic) and Bank branche(per 100,000 adults) of Fiji?
Provide a succinct answer. -9.44. In the year 2009, what is the difference between the Bank branche(per 100,000 adults) of Congo (Republic) and Bank branche(per 100,000 adults) of Poland?
Provide a succinct answer. -31.02. In the year 2009, what is the difference between the Bank branche(per 100,000 adults) of Fiji and Bank branche(per 100,000 adults) of Poland?
Your response must be concise. -21.58. In the year 2010, what is the difference between the Bank branche(per 100,000 adults) of High income: nonOECD and Bank branche(per 100,000 adults) of Congo (Republic)?
Provide a succinct answer. 15.52. In the year 2010, what is the difference between the Bank branche(per 100,000 adults) of High income: nonOECD and Bank branche(per 100,000 adults) of Fiji?
Offer a terse response. 6.57. In the year 2010, what is the difference between the Bank branche(per 100,000 adults) of High income: nonOECD and Bank branche(per 100,000 adults) of Poland?
Provide a short and direct response. -14.4. In the year 2010, what is the difference between the Bank branche(per 100,000 adults) in Congo (Republic) and Bank branche(per 100,000 adults) in Fiji?
Make the answer very short. -8.95. In the year 2010, what is the difference between the Bank branche(per 100,000 adults) in Congo (Republic) and Bank branche(per 100,000 adults) in Poland?
Your answer should be compact. -29.92. In the year 2010, what is the difference between the Bank branche(per 100,000 adults) in Fiji and Bank branche(per 100,000 adults) in Poland?
Provide a short and direct response. -20.97. What is the ratio of the Bank branche(per 100,000 adults) of High income: nonOECD in 2004 to that in 2005?
Provide a short and direct response. 1.1. What is the ratio of the Bank branche(per 100,000 adults) in Congo (Republic) in 2004 to that in 2005?
Provide a succinct answer. 1.03. What is the ratio of the Bank branche(per 100,000 adults) in Fiji in 2004 to that in 2005?
Make the answer very short. 0.96. What is the ratio of the Bank branche(per 100,000 adults) of High income: nonOECD in 2004 to that in 2006?
Provide a succinct answer. 1.05. What is the ratio of the Bank branche(per 100,000 adults) in Congo (Republic) in 2004 to that in 2006?
Ensure brevity in your answer.  1.06. What is the ratio of the Bank branche(per 100,000 adults) in Fiji in 2004 to that in 2006?
Provide a succinct answer. 0.88. What is the ratio of the Bank branche(per 100,000 adults) of Poland in 2004 to that in 2006?
Provide a short and direct response. 0.96. What is the ratio of the Bank branche(per 100,000 adults) of High income: nonOECD in 2004 to that in 2007?
Your response must be concise. 0.94. What is the ratio of the Bank branche(per 100,000 adults) of Congo (Republic) in 2004 to that in 2007?
Make the answer very short. 0.48. What is the ratio of the Bank branche(per 100,000 adults) of Fiji in 2004 to that in 2007?
Your response must be concise. 0.82. What is the ratio of the Bank branche(per 100,000 adults) of Poland in 2004 to that in 2007?
Your answer should be very brief. 0.9. What is the ratio of the Bank branche(per 100,000 adults) of High income: nonOECD in 2004 to that in 2008?
Offer a very short reply. 0.93. What is the ratio of the Bank branche(per 100,000 adults) in Congo (Republic) in 2004 to that in 2008?
Make the answer very short. 0.39. What is the ratio of the Bank branche(per 100,000 adults) in Fiji in 2004 to that in 2008?
Provide a succinct answer. 0.8. What is the ratio of the Bank branche(per 100,000 adults) of Poland in 2004 to that in 2008?
Your answer should be compact. 0.81. What is the ratio of the Bank branche(per 100,000 adults) in High income: nonOECD in 2004 to that in 2009?
Offer a terse response. 0.95. What is the ratio of the Bank branche(per 100,000 adults) of Congo (Republic) in 2004 to that in 2009?
Give a very brief answer. 0.39. What is the ratio of the Bank branche(per 100,000 adults) in Fiji in 2004 to that in 2009?
Your answer should be very brief. 0.82. What is the ratio of the Bank branche(per 100,000 adults) of Poland in 2004 to that in 2009?
Your response must be concise. 0.81. What is the ratio of the Bank branche(per 100,000 adults) of High income: nonOECD in 2004 to that in 2010?
Your answer should be compact. 0.98. What is the ratio of the Bank branche(per 100,000 adults) in Congo (Republic) in 2004 to that in 2010?
Offer a very short reply. 0.32. What is the ratio of the Bank branche(per 100,000 adults) in Fiji in 2004 to that in 2010?
Give a very brief answer. 0.83. What is the ratio of the Bank branche(per 100,000 adults) in Poland in 2004 to that in 2010?
Offer a very short reply. 0.83. What is the ratio of the Bank branche(per 100,000 adults) of High income: nonOECD in 2005 to that in 2006?
Your answer should be compact. 0.95. What is the ratio of the Bank branche(per 100,000 adults) in Fiji in 2005 to that in 2006?
Offer a terse response. 0.92. What is the ratio of the Bank branche(per 100,000 adults) in High income: nonOECD in 2005 to that in 2007?
Provide a succinct answer. 0.86. What is the ratio of the Bank branche(per 100,000 adults) in Congo (Republic) in 2005 to that in 2007?
Keep it short and to the point. 0.46. What is the ratio of the Bank branche(per 100,000 adults) of Fiji in 2005 to that in 2007?
Give a very brief answer. 0.86. What is the ratio of the Bank branche(per 100,000 adults) in Poland in 2005 to that in 2007?
Your answer should be very brief. 0.9. What is the ratio of the Bank branche(per 100,000 adults) in High income: nonOECD in 2005 to that in 2008?
Make the answer very short. 0.85. What is the ratio of the Bank branche(per 100,000 adults) in Congo (Republic) in 2005 to that in 2008?
Provide a succinct answer. 0.38. What is the ratio of the Bank branche(per 100,000 adults) of Fiji in 2005 to that in 2008?
Provide a short and direct response. 0.83. What is the ratio of the Bank branche(per 100,000 adults) of Poland in 2005 to that in 2008?
Make the answer very short. 0.81. What is the ratio of the Bank branche(per 100,000 adults) in High income: nonOECD in 2005 to that in 2009?
Provide a short and direct response. 0.86. What is the ratio of the Bank branche(per 100,000 adults) in Congo (Republic) in 2005 to that in 2009?
Offer a terse response. 0.38. What is the ratio of the Bank branche(per 100,000 adults) in Fiji in 2005 to that in 2009?
Offer a very short reply. 0.86. What is the ratio of the Bank branche(per 100,000 adults) in Poland in 2005 to that in 2009?
Provide a succinct answer. 0.81. What is the ratio of the Bank branche(per 100,000 adults) in High income: nonOECD in 2005 to that in 2010?
Offer a terse response. 0.89. What is the ratio of the Bank branche(per 100,000 adults) of Congo (Republic) in 2005 to that in 2010?
Offer a terse response. 0.31. What is the ratio of the Bank branche(per 100,000 adults) of Fiji in 2005 to that in 2010?
Ensure brevity in your answer.  0.87. What is the ratio of the Bank branche(per 100,000 adults) in Poland in 2005 to that in 2010?
Offer a very short reply. 0.83. What is the ratio of the Bank branche(per 100,000 adults) of High income: nonOECD in 2006 to that in 2007?
Keep it short and to the point. 0.9. What is the ratio of the Bank branche(per 100,000 adults) of Congo (Republic) in 2006 to that in 2007?
Keep it short and to the point. 0.45. What is the ratio of the Bank branche(per 100,000 adults) in Fiji in 2006 to that in 2007?
Make the answer very short. 0.94. What is the ratio of the Bank branche(per 100,000 adults) of Poland in 2006 to that in 2007?
Provide a succinct answer. 0.93. What is the ratio of the Bank branche(per 100,000 adults) in High income: nonOECD in 2006 to that in 2008?
Your answer should be compact. 0.89. What is the ratio of the Bank branche(per 100,000 adults) of Congo (Republic) in 2006 to that in 2008?
Ensure brevity in your answer.  0.37. What is the ratio of the Bank branche(per 100,000 adults) of Fiji in 2006 to that in 2008?
Give a very brief answer. 0.91. What is the ratio of the Bank branche(per 100,000 adults) in Poland in 2006 to that in 2008?
Provide a short and direct response. 0.84. What is the ratio of the Bank branche(per 100,000 adults) of High income: nonOECD in 2006 to that in 2009?
Your response must be concise. 0.91. What is the ratio of the Bank branche(per 100,000 adults) of Congo (Republic) in 2006 to that in 2009?
Keep it short and to the point. 0.37. What is the ratio of the Bank branche(per 100,000 adults) of Fiji in 2006 to that in 2009?
Your answer should be compact. 0.93. What is the ratio of the Bank branche(per 100,000 adults) of Poland in 2006 to that in 2009?
Ensure brevity in your answer.  0.84. What is the ratio of the Bank branche(per 100,000 adults) in High income: nonOECD in 2006 to that in 2010?
Ensure brevity in your answer.  0.93. What is the ratio of the Bank branche(per 100,000 adults) in Congo (Republic) in 2006 to that in 2010?
Give a very brief answer. 0.3. What is the ratio of the Bank branche(per 100,000 adults) in Fiji in 2006 to that in 2010?
Your answer should be compact. 0.95. What is the ratio of the Bank branche(per 100,000 adults) in Poland in 2006 to that in 2010?
Your answer should be compact. 0.86. What is the ratio of the Bank branche(per 100,000 adults) of High income: nonOECD in 2007 to that in 2008?
Provide a short and direct response. 0.99. What is the ratio of the Bank branche(per 100,000 adults) of Congo (Republic) in 2007 to that in 2008?
Keep it short and to the point. 0.83. What is the ratio of the Bank branche(per 100,000 adults) in Fiji in 2007 to that in 2008?
Offer a terse response. 0.97. What is the ratio of the Bank branche(per 100,000 adults) of Poland in 2007 to that in 2008?
Your answer should be very brief. 0.91. What is the ratio of the Bank branche(per 100,000 adults) of Congo (Republic) in 2007 to that in 2009?
Keep it short and to the point. 0.81. What is the ratio of the Bank branche(per 100,000 adults) of Fiji in 2007 to that in 2009?
Provide a succinct answer. 1. What is the ratio of the Bank branche(per 100,000 adults) of Poland in 2007 to that in 2009?
Your answer should be compact. 0.9. What is the ratio of the Bank branche(per 100,000 adults) in High income: nonOECD in 2007 to that in 2010?
Your answer should be compact. 1.04. What is the ratio of the Bank branche(per 100,000 adults) of Congo (Republic) in 2007 to that in 2010?
Ensure brevity in your answer.  0.67. What is the ratio of the Bank branche(per 100,000 adults) of Fiji in 2007 to that in 2010?
Provide a short and direct response. 1.01. What is the ratio of the Bank branche(per 100,000 adults) in Poland in 2007 to that in 2010?
Your answer should be compact. 0.92. What is the ratio of the Bank branche(per 100,000 adults) of High income: nonOECD in 2008 to that in 2009?
Offer a terse response. 1.02. What is the ratio of the Bank branche(per 100,000 adults) of Congo (Republic) in 2008 to that in 2009?
Provide a succinct answer. 0.98. What is the ratio of the Bank branche(per 100,000 adults) of Fiji in 2008 to that in 2009?
Ensure brevity in your answer.  1.03. What is the ratio of the Bank branche(per 100,000 adults) in Poland in 2008 to that in 2009?
Your answer should be very brief. 0.99. What is the ratio of the Bank branche(per 100,000 adults) in High income: nonOECD in 2008 to that in 2010?
Provide a short and direct response. 1.05. What is the ratio of the Bank branche(per 100,000 adults) of Congo (Republic) in 2008 to that in 2010?
Offer a very short reply. 0.82. What is the ratio of the Bank branche(per 100,000 adults) in Fiji in 2008 to that in 2010?
Your answer should be very brief. 1.04. What is the ratio of the Bank branche(per 100,000 adults) in Poland in 2008 to that in 2010?
Give a very brief answer. 1.02. What is the ratio of the Bank branche(per 100,000 adults) of High income: nonOECD in 2009 to that in 2010?
Provide a short and direct response. 1.03. What is the ratio of the Bank branche(per 100,000 adults) of Congo (Republic) in 2009 to that in 2010?
Give a very brief answer. 0.83. What is the ratio of the Bank branche(per 100,000 adults) of Fiji in 2009 to that in 2010?
Your answer should be very brief. 1.01. What is the ratio of the Bank branche(per 100,000 adults) of Poland in 2009 to that in 2010?
Offer a terse response. 1.02. What is the difference between the highest and the second highest Bank branche(per 100,000 adults) in High income: nonOECD?
Provide a short and direct response. 0.26. What is the difference between the highest and the second highest Bank branche(per 100,000 adults) of Congo (Republic)?
Provide a succinct answer. 0.37. What is the difference between the highest and the second highest Bank branche(per 100,000 adults) of Fiji?
Provide a succinct answer. 0.31. What is the difference between the highest and the second highest Bank branche(per 100,000 adults) in Poland?
Your answer should be compact. 0.19. What is the difference between the highest and the lowest Bank branche(per 100,000 adults) of High income: nonOECD?
Provide a succinct answer. 2.87. What is the difference between the highest and the lowest Bank branche(per 100,000 adults) of Congo (Republic)?
Your response must be concise. 1.52. What is the difference between the highest and the lowest Bank branche(per 100,000 adults) of Fiji?
Provide a succinct answer. 2.32. What is the difference between the highest and the lowest Bank branche(per 100,000 adults) in Poland?
Your answer should be compact. 6.31. 